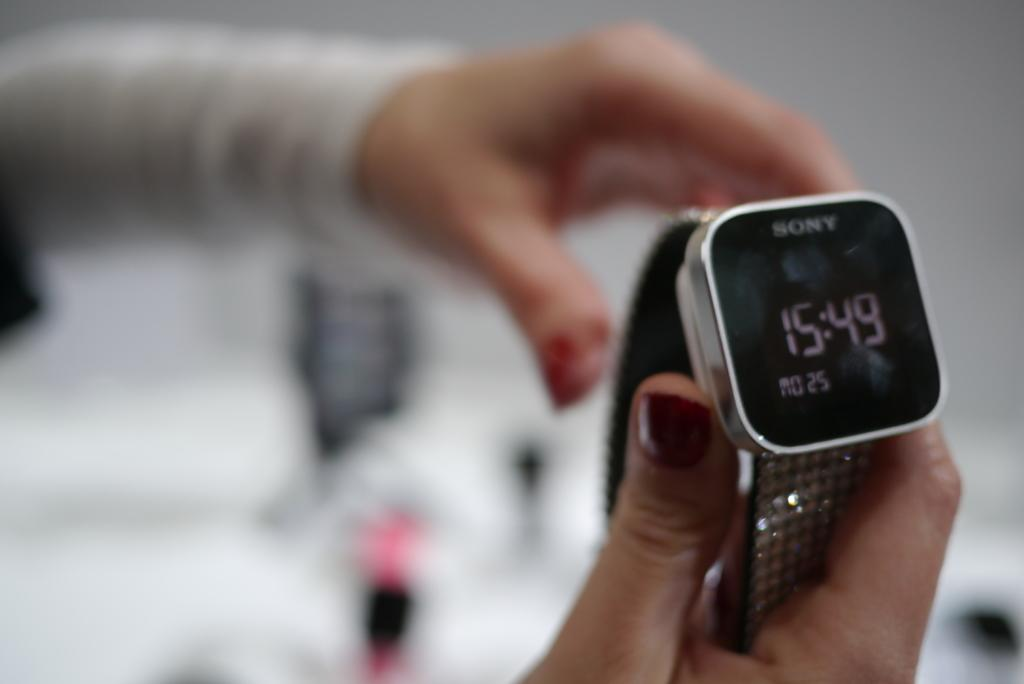What type of timepiece is present in the image? There is a digital watch in the image. What part of a person can be seen in the image? The hands of a person are visible in the image. How would you describe the background of the image? The background of the image is blurry. What color is the crayon used to draw the watch in the image? There is no crayon or drawing present in the image; it features a real digital watch. 